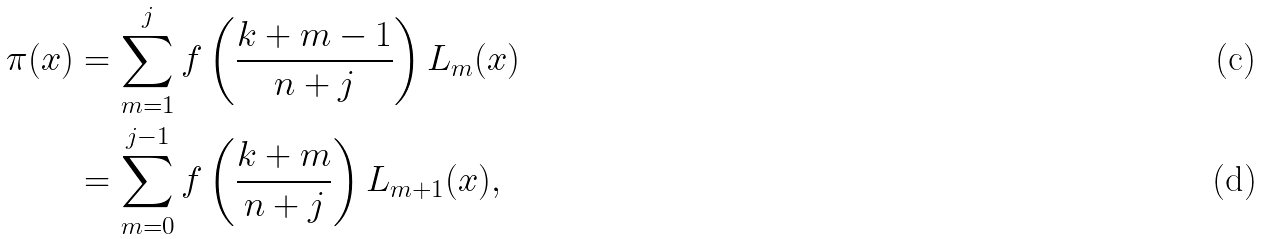<formula> <loc_0><loc_0><loc_500><loc_500>\pi ( x ) & = \sum _ { m = 1 } ^ { j } f \left ( \frac { k + m - 1 } { n + j } \right ) L _ { m } ( x ) \\ & = \sum _ { m = 0 } ^ { j - 1 } f \left ( \frac { k + m } { n + j } \right ) L _ { m + 1 } ( x ) ,</formula> 